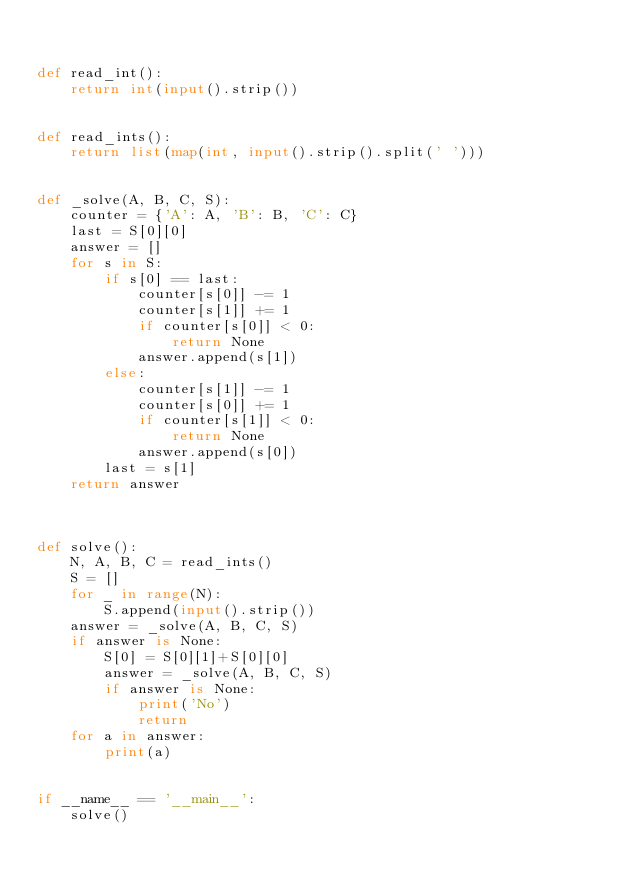<code> <loc_0><loc_0><loc_500><loc_500><_Python_>

def read_int():
    return int(input().strip())


def read_ints():
    return list(map(int, input().strip().split(' ')))


def _solve(A, B, C, S):
    counter = {'A': A, 'B': B, 'C': C}
    last = S[0][0]
    answer = []
    for s in S:
        if s[0] == last:
            counter[s[0]] -= 1
            counter[s[1]] += 1
            if counter[s[0]] < 0:
                return None
            answer.append(s[1])
        else:
            counter[s[1]] -= 1
            counter[s[0]] += 1
            if counter[s[1]] < 0:
                return None
            answer.append(s[0])
        last = s[1]
    return answer



def solve():
    N, A, B, C = read_ints()
    S = []
    for _ in range(N):
        S.append(input().strip())
    answer = _solve(A, B, C, S)
    if answer is None:
        S[0] = S[0][1]+S[0][0]
        answer = _solve(A, B, C, S)
        if answer is None:
            print('No')
            return
    for a in answer:
        print(a)


if __name__ == '__main__':
    solve()
</code> 